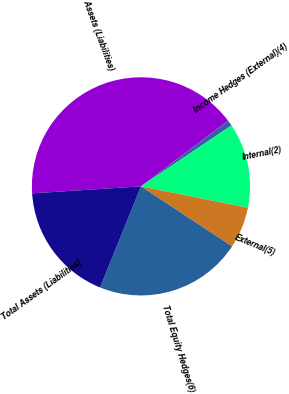Convert chart to OTSL. <chart><loc_0><loc_0><loc_500><loc_500><pie_chart><fcel>Assets (Liabilities)<fcel>Income Hedges (External)(4)<fcel>Internal(2)<fcel>External(5)<fcel>Total Equity Hedges(6)<fcel>Total Assets (Liabilities)<nl><fcel>40.74%<fcel>0.85%<fcel>12.58%<fcel>6.12%<fcel>21.85%<fcel>17.86%<nl></chart> 